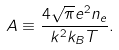Convert formula to latex. <formula><loc_0><loc_0><loc_500><loc_500>A \equiv \frac { 4 \sqrt { \pi } e ^ { 2 } n _ { e } } { k ^ { 2 } k _ { B } T } .</formula> 